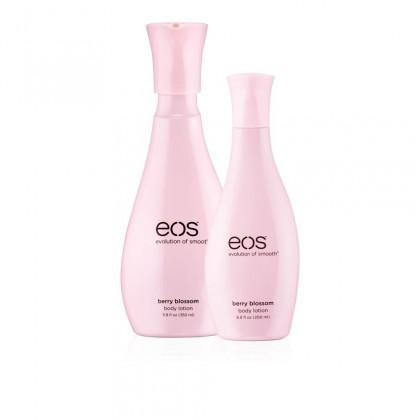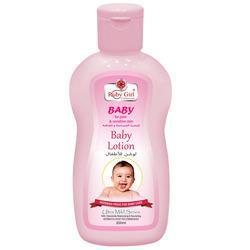The first image is the image on the left, the second image is the image on the right. For the images displayed, is the sentence "there is a single bottle with a pump top" factually correct? Answer yes or no. No. The first image is the image on the left, the second image is the image on the right. Examine the images to the left and right. Is the description "There are three items." accurate? Answer yes or no. Yes. 